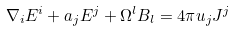Convert formula to latex. <formula><loc_0><loc_0><loc_500><loc_500>\nabla _ { i } E ^ { i } + a _ { j } E ^ { j } + \Omega ^ { l } B _ { l } = 4 \pi u _ { j } J ^ { j }</formula> 